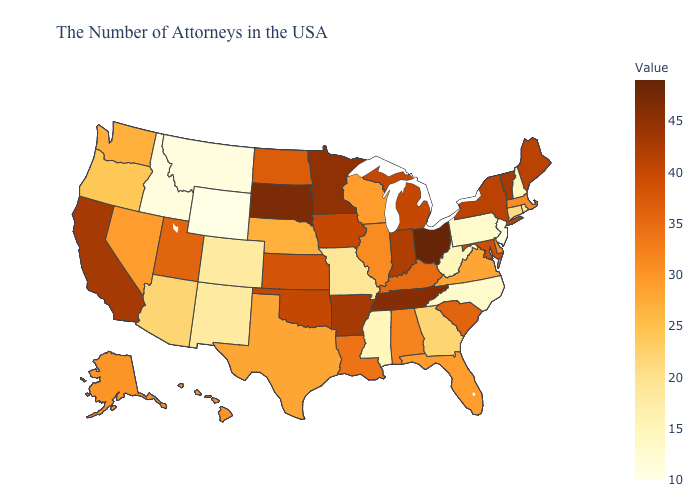Does Louisiana have the highest value in the USA?
Give a very brief answer. No. Does the map have missing data?
Give a very brief answer. No. Among the states that border Colorado , does Oklahoma have the highest value?
Keep it brief. Yes. Does the map have missing data?
Quick response, please. No. Does Oklahoma have the highest value in the USA?
Be succinct. No. Does Alaska have the lowest value in the USA?
Give a very brief answer. No. Among the states that border North Carolina , which have the highest value?
Concise answer only. Tennessee. 